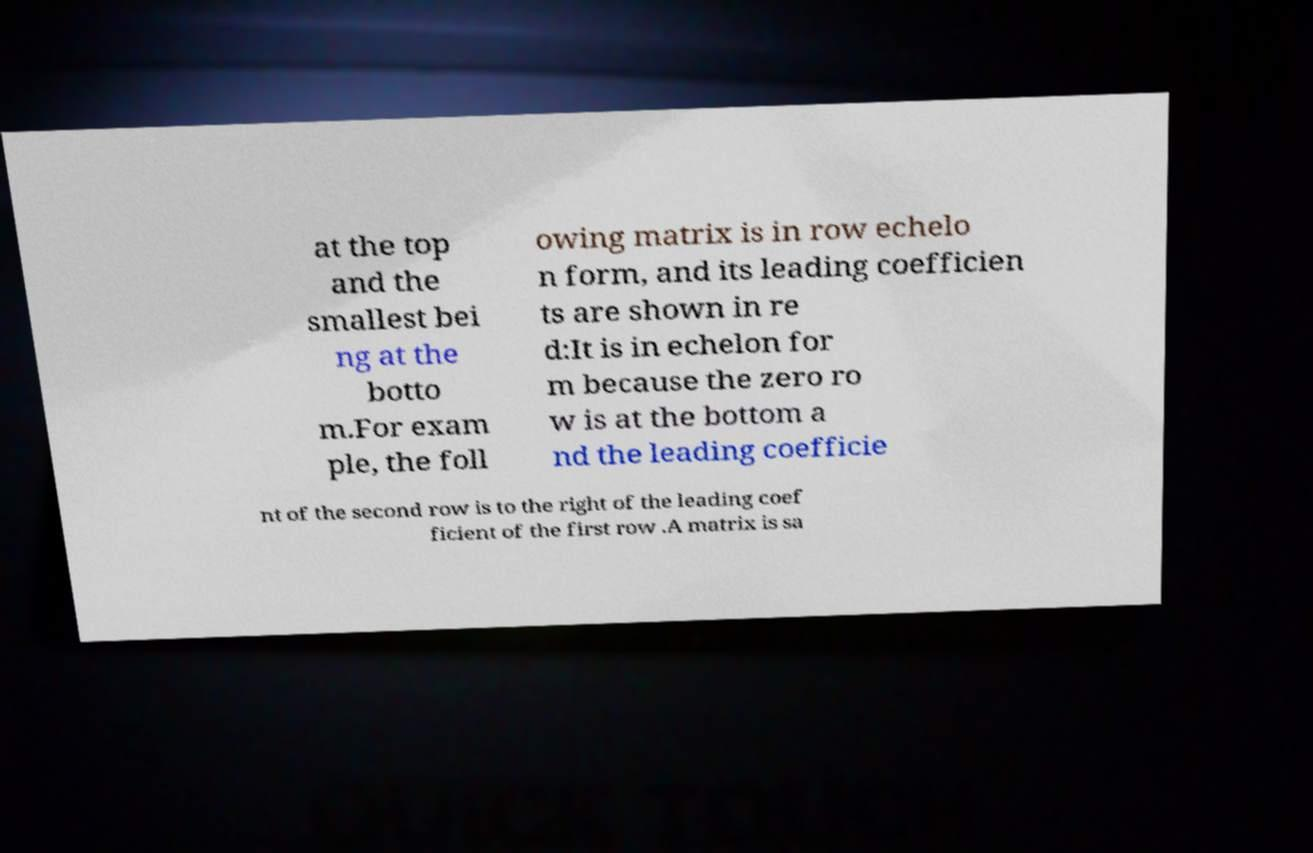I need the written content from this picture converted into text. Can you do that? at the top and the smallest bei ng at the botto m.For exam ple, the foll owing matrix is in row echelo n form, and its leading coefficien ts are shown in re d:It is in echelon for m because the zero ro w is at the bottom a nd the leading coefficie nt of the second row is to the right of the leading coef ficient of the first row .A matrix is sa 